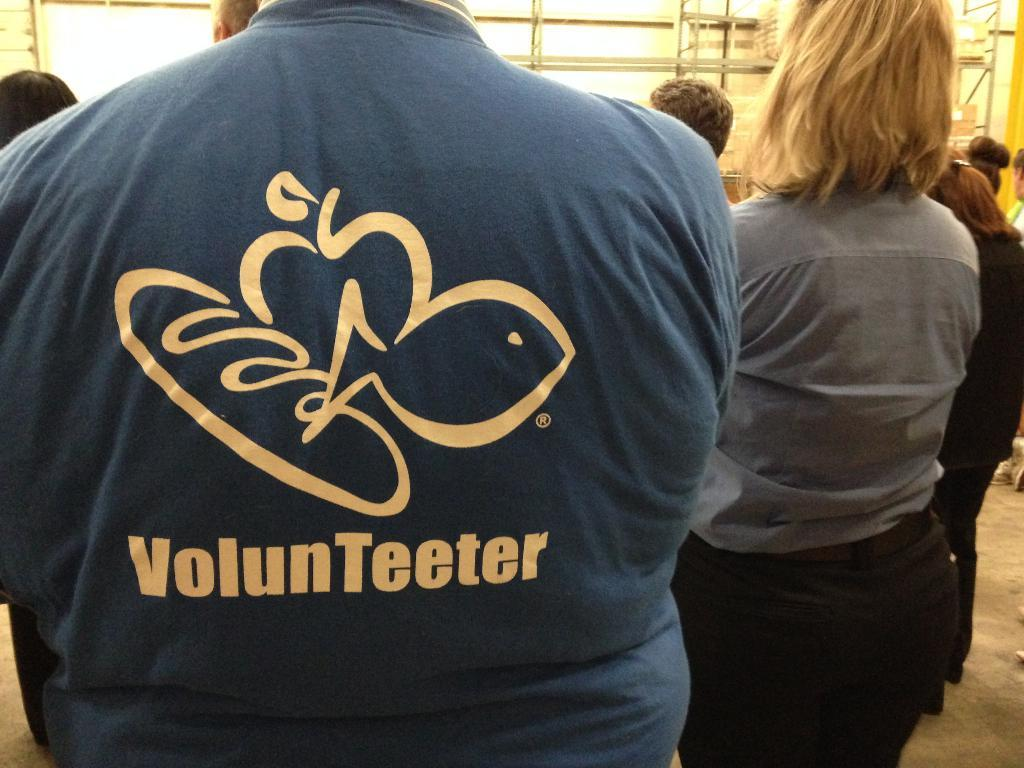<image>
Provide a brief description of the given image. A person is wearing a shirt that says "volunteeter" on the back. 